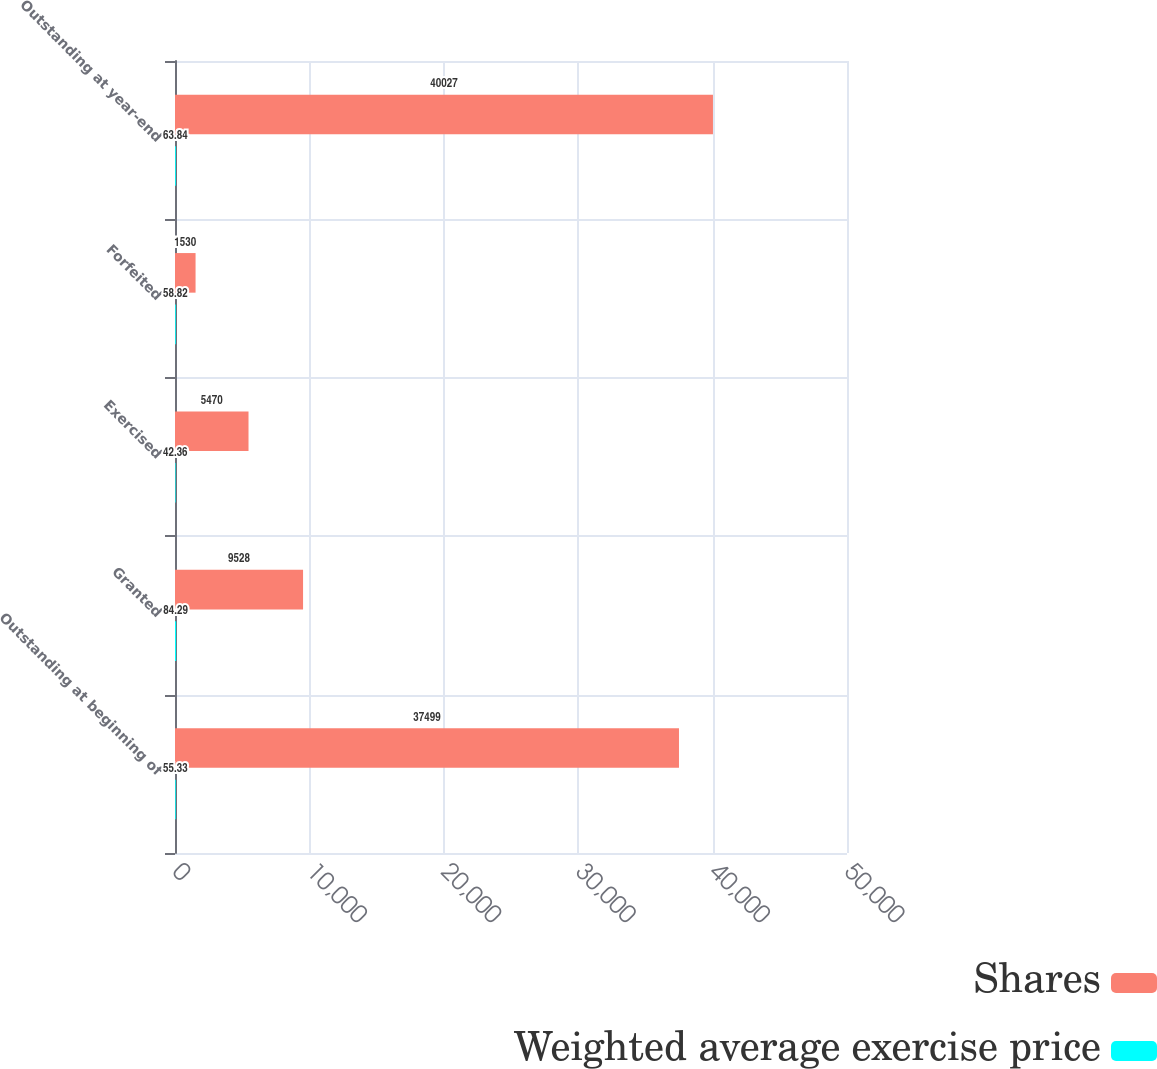Convert chart. <chart><loc_0><loc_0><loc_500><loc_500><stacked_bar_chart><ecel><fcel>Outstanding at beginning of<fcel>Granted<fcel>Exercised<fcel>Forfeited<fcel>Outstanding at year-end<nl><fcel>Shares<fcel>37499<fcel>9528<fcel>5470<fcel>1530<fcel>40027<nl><fcel>Weighted average exercise price<fcel>55.33<fcel>84.29<fcel>42.36<fcel>58.82<fcel>63.84<nl></chart> 